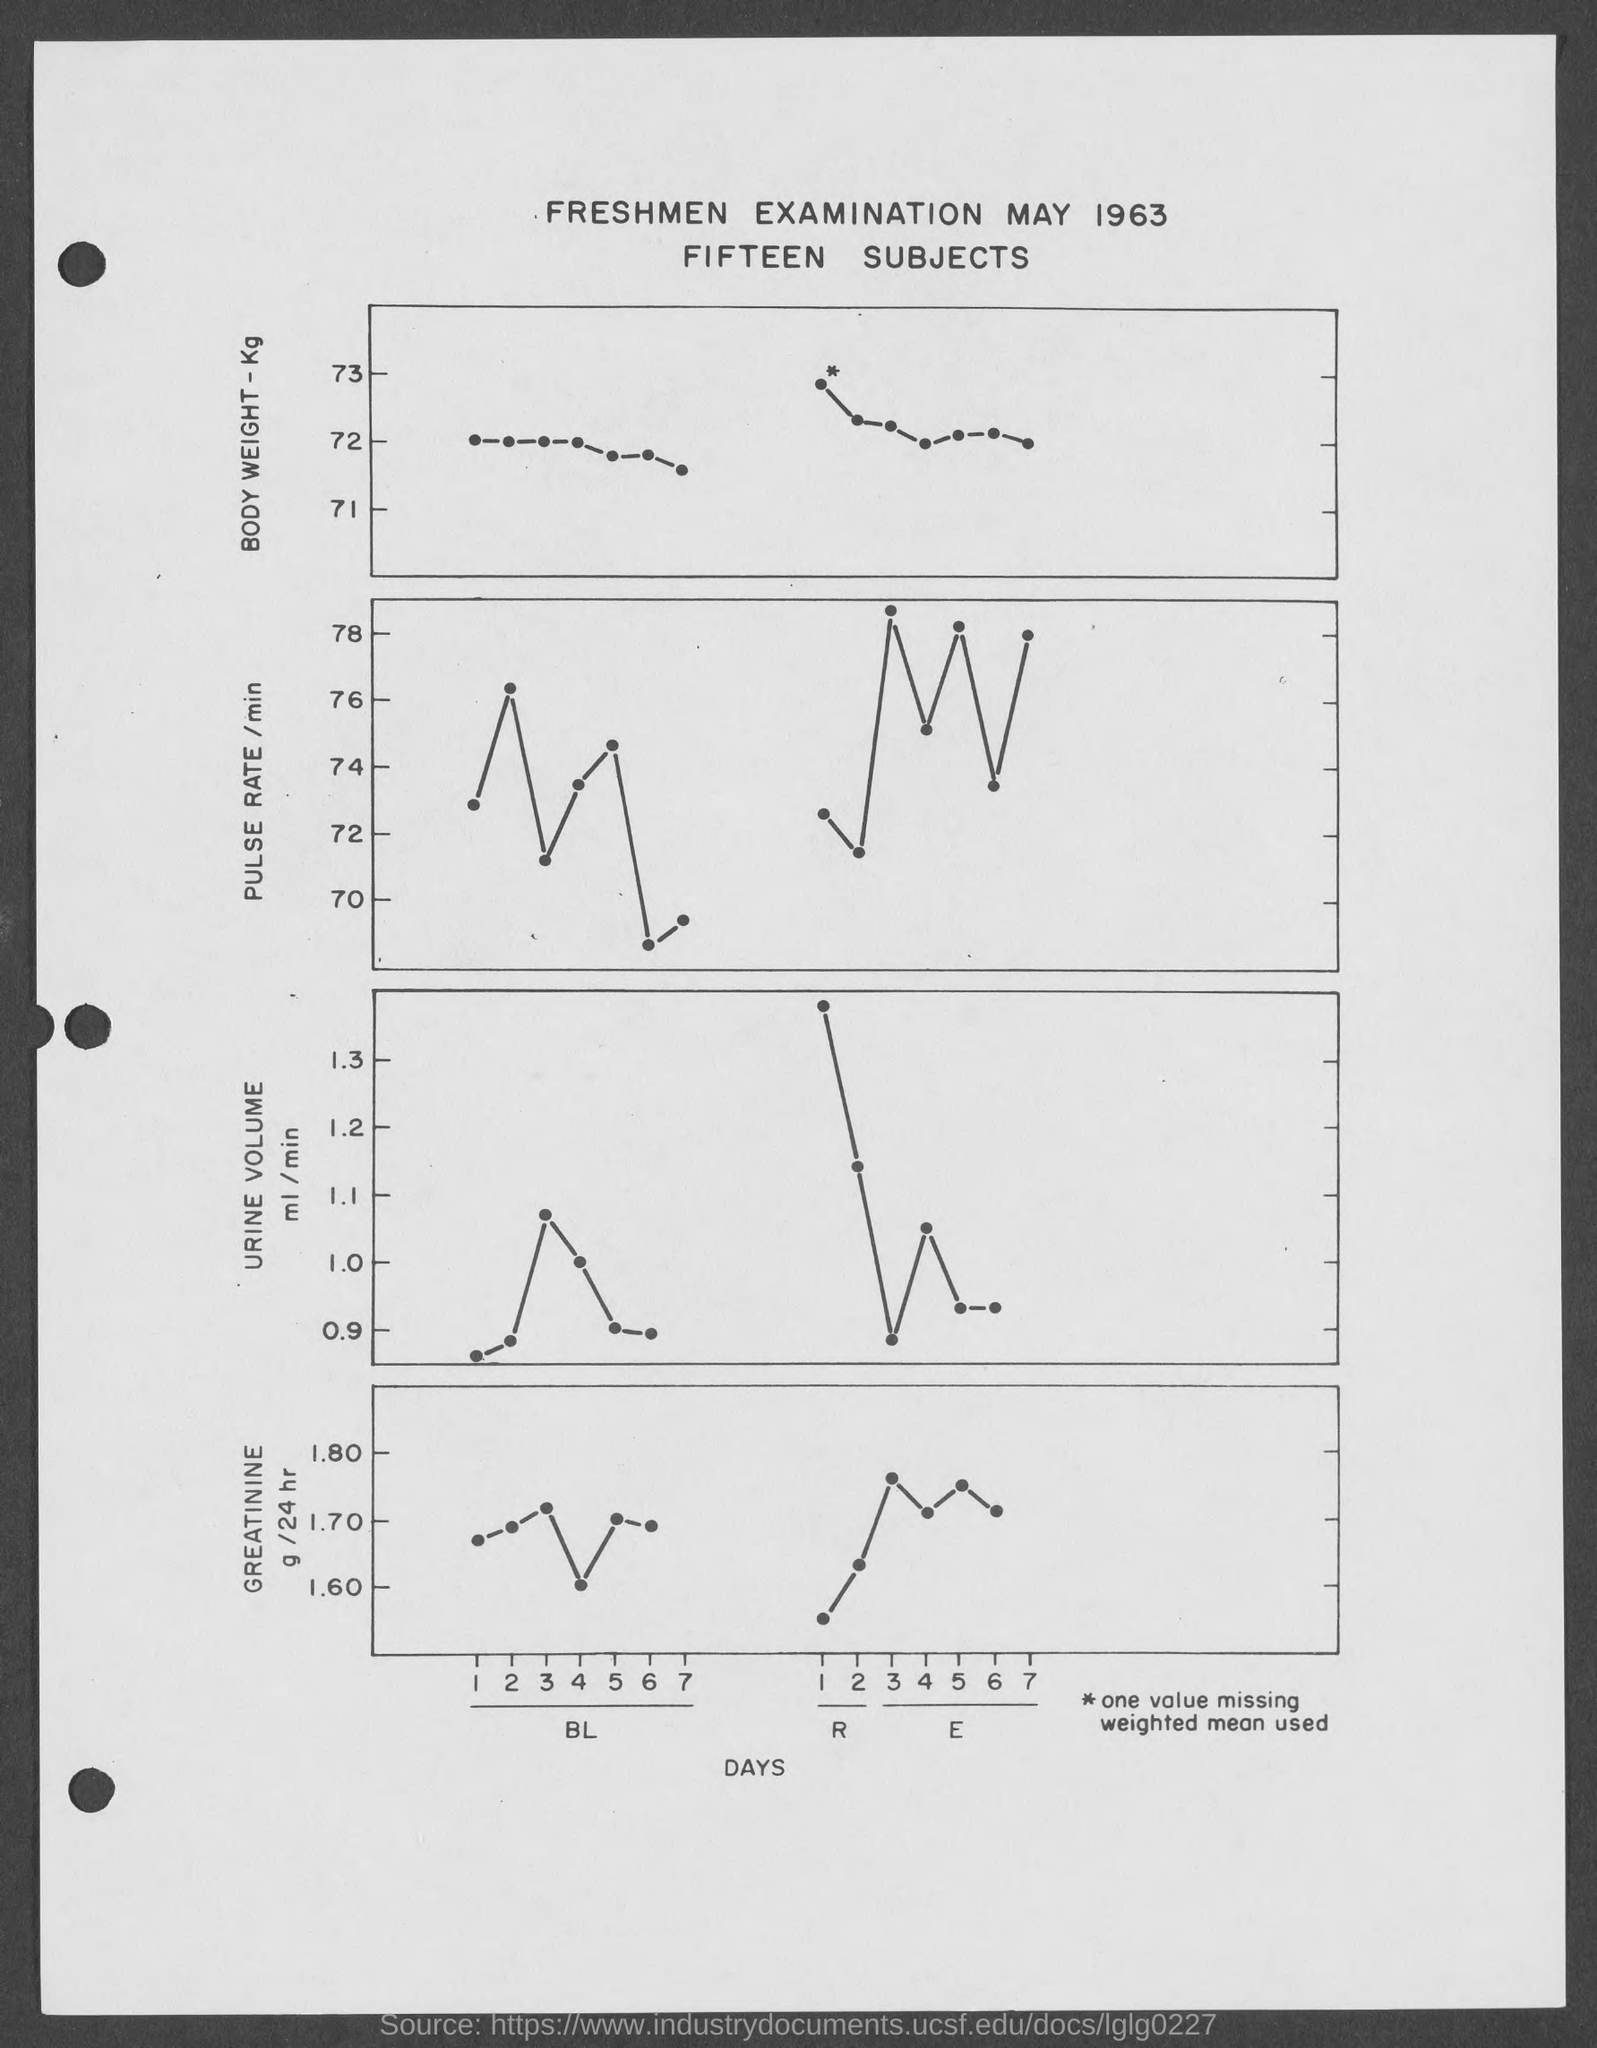Draw attention to some important aspects in this diagram. The x-axis of all graphs is the horizontal axis, and it is typically labeled with the date or time. The first title in the document is "Freshmen Examination May 1963. The second title in the document is "Fifteen Subjects. 